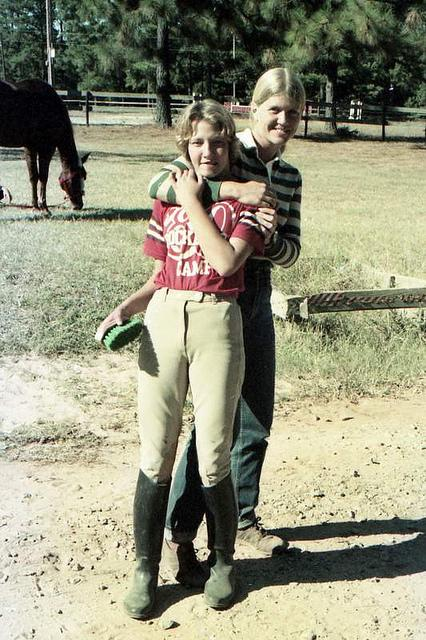What will she use the brush for? horse 